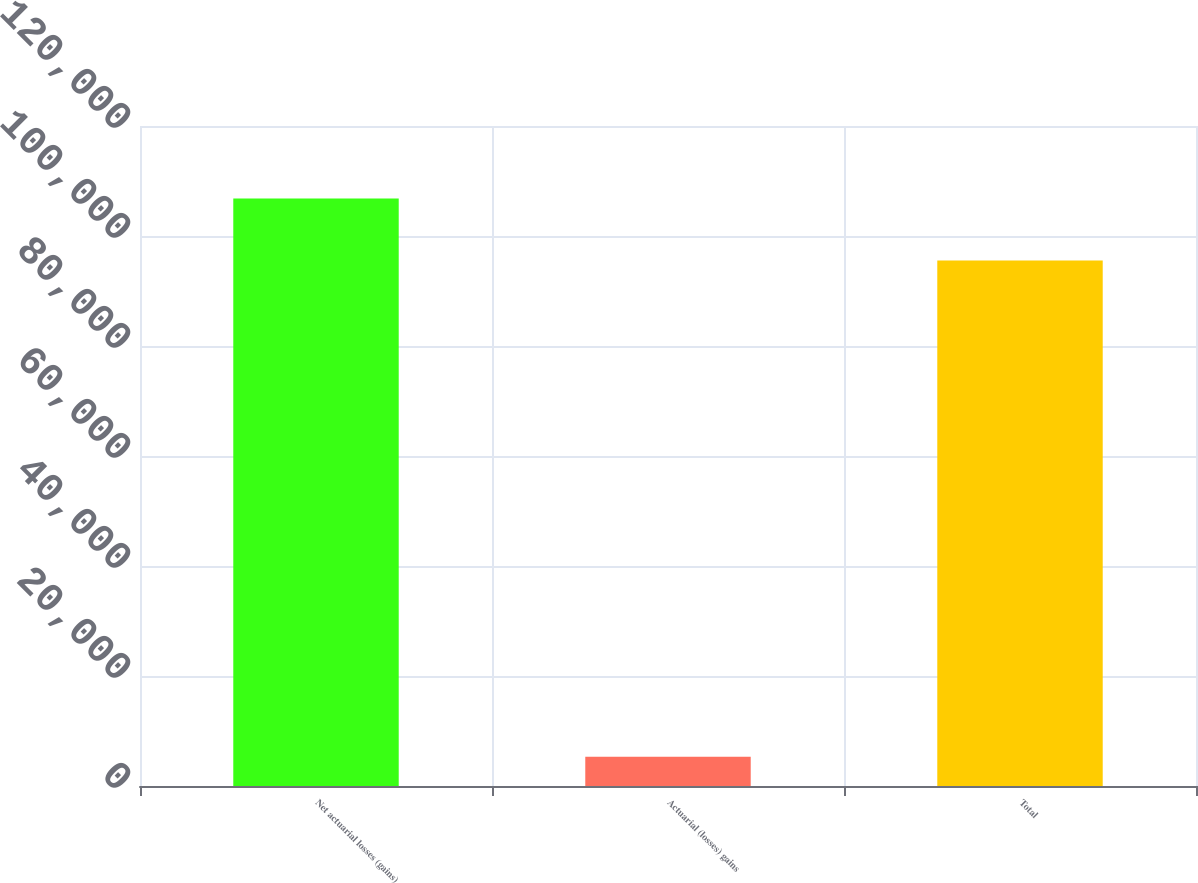Convert chart. <chart><loc_0><loc_0><loc_500><loc_500><bar_chart><fcel>Net actuarial losses (gains)<fcel>Actuarial (losses) gains<fcel>Total<nl><fcel>106837<fcel>5310<fcel>95527<nl></chart> 